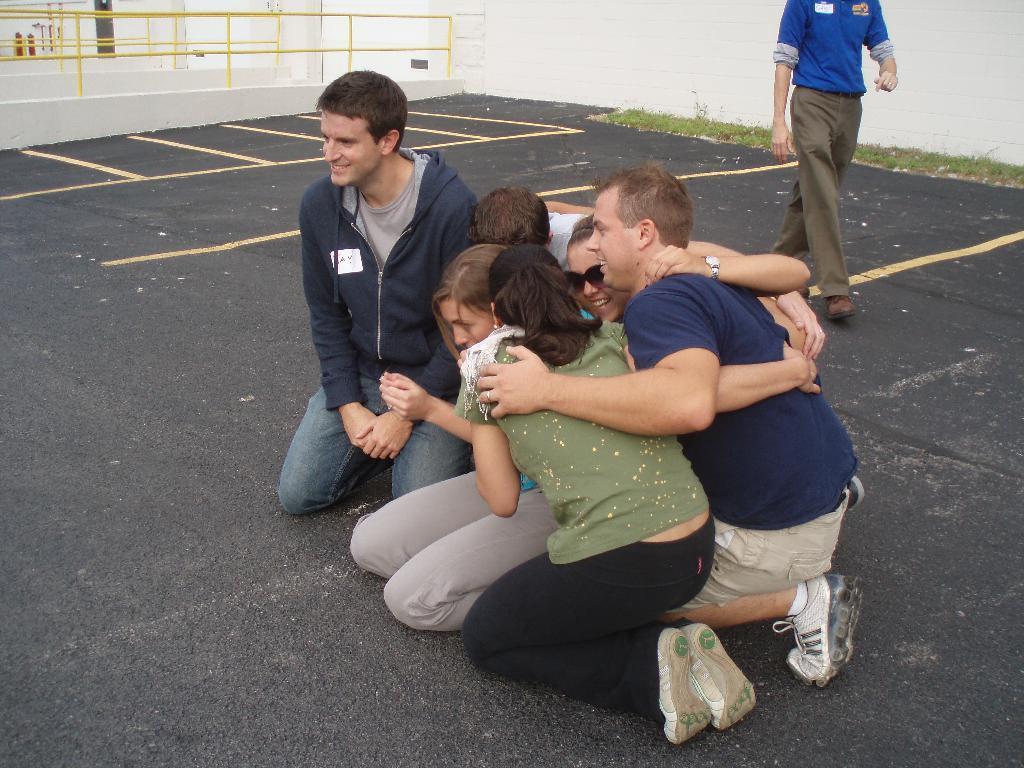What are the people in the image engaged in any activity? Yes, there is a group of people sitting on the road, and a person is walking behind the group. What can be seen on the left side of the image? Metal fencing is present on the left side of the image. What type of sticks are being used by the people to create a range of soap in the image? There are no sticks, range, or soap present in the image. 